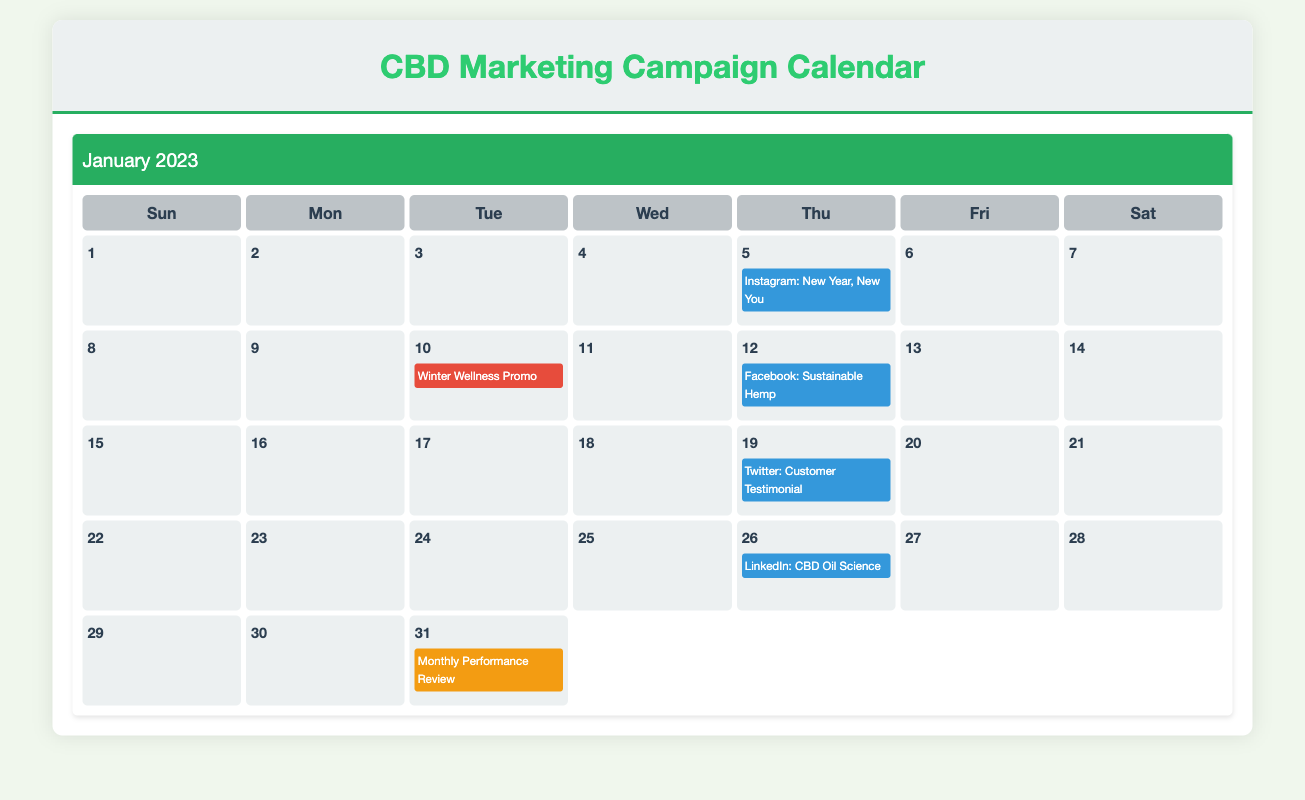What social media post is planned for January 5? The document specifies that the Instagram post titled "New Year, New You" is scheduled for January 5.
Answer: Instagram: New Year, New You What ad campaign is launching on January 10? The document indicates that the "Winter Wellness Promo" ad campaign is set to launch on January 10.
Answer: Winter Wellness Promo How many social media posts are scheduled in January? By counting the specific social media events listed, there are four social media posts in January.
Answer: 4 What is the date of the Monthly Performance Review? The document notes that the Monthly Performance Review is scheduled for January 31.
Answer: January 31 Which platform is highlighted for the customer testimonial post? According to the document, Twitter is the platform designated for the customer testimonial post on January 19.
Answer: Twitter What color represents the analytics review session in the calendar? The analytics review session is represented in orange color in the document.
Answer: Orange How often do analytics review sessions occur within this calendar? The document shows that there is one analytics review session for the month of January.
Answer: Once What type of content is scheduled for January 12? The document confirms that a Facebook post about Sustainable Hemp is scheduled for January 12.
Answer: Facebook: Sustainable Hemp On which date does the event for LinkedIn occur? The document specifies that the LinkedIn event is scheduled for January 26.
Answer: January 26 